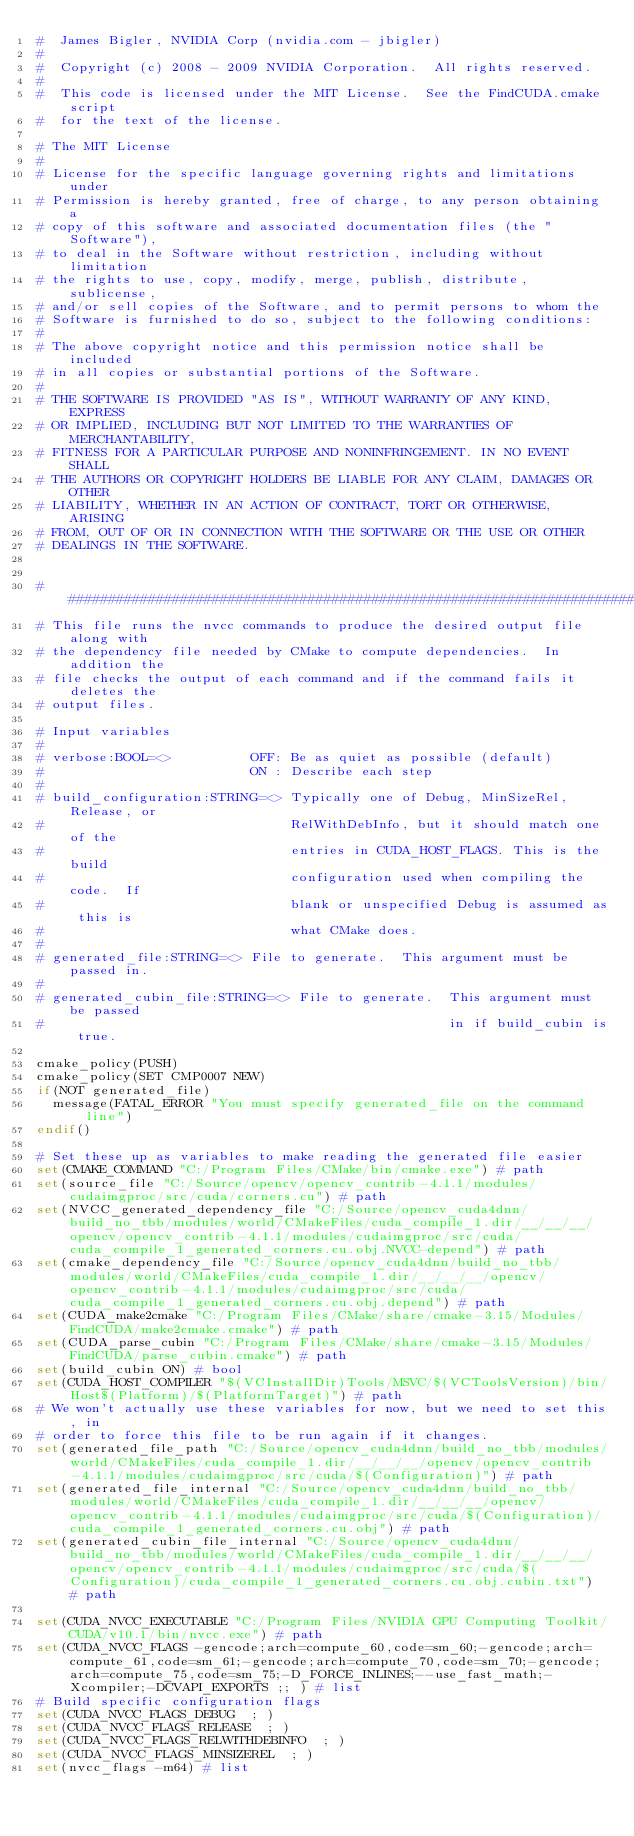<code> <loc_0><loc_0><loc_500><loc_500><_CMake_>#  James Bigler, NVIDIA Corp (nvidia.com - jbigler)
#
#  Copyright (c) 2008 - 2009 NVIDIA Corporation.  All rights reserved.
#
#  This code is licensed under the MIT License.  See the FindCUDA.cmake script
#  for the text of the license.

# The MIT License
#
# License for the specific language governing rights and limitations under
# Permission is hereby granted, free of charge, to any person obtaining a
# copy of this software and associated documentation files (the "Software"),
# to deal in the Software without restriction, including without limitation
# the rights to use, copy, modify, merge, publish, distribute, sublicense,
# and/or sell copies of the Software, and to permit persons to whom the
# Software is furnished to do so, subject to the following conditions:
#
# The above copyright notice and this permission notice shall be included
# in all copies or substantial portions of the Software.
#
# THE SOFTWARE IS PROVIDED "AS IS", WITHOUT WARRANTY OF ANY KIND, EXPRESS
# OR IMPLIED, INCLUDING BUT NOT LIMITED TO THE WARRANTIES OF MERCHANTABILITY,
# FITNESS FOR A PARTICULAR PURPOSE AND NONINFRINGEMENT. IN NO EVENT SHALL
# THE AUTHORS OR COPYRIGHT HOLDERS BE LIABLE FOR ANY CLAIM, DAMAGES OR OTHER
# LIABILITY, WHETHER IN AN ACTION OF CONTRACT, TORT OR OTHERWISE, ARISING
# FROM, OUT OF OR IN CONNECTION WITH THE SOFTWARE OR THE USE OR OTHER
# DEALINGS IN THE SOFTWARE.


##########################################################################
# This file runs the nvcc commands to produce the desired output file along with
# the dependency file needed by CMake to compute dependencies.  In addition the
# file checks the output of each command and if the command fails it deletes the
# output files.

# Input variables
#
# verbose:BOOL=<>          OFF: Be as quiet as possible (default)
#                          ON : Describe each step
#
# build_configuration:STRING=<> Typically one of Debug, MinSizeRel, Release, or
#                               RelWithDebInfo, but it should match one of the
#                               entries in CUDA_HOST_FLAGS. This is the build
#                               configuration used when compiling the code.  If
#                               blank or unspecified Debug is assumed as this is
#                               what CMake does.
#
# generated_file:STRING=<> File to generate.  This argument must be passed in.
#
# generated_cubin_file:STRING=<> File to generate.  This argument must be passed
#                                                   in if build_cubin is true.

cmake_policy(PUSH)
cmake_policy(SET CMP0007 NEW)
if(NOT generated_file)
  message(FATAL_ERROR "You must specify generated_file on the command line")
endif()

# Set these up as variables to make reading the generated file easier
set(CMAKE_COMMAND "C:/Program Files/CMake/bin/cmake.exe") # path
set(source_file "C:/Source/opencv/opencv_contrib-4.1.1/modules/cudaimgproc/src/cuda/corners.cu") # path
set(NVCC_generated_dependency_file "C:/Source/opencv_cuda4dnn/build_no_tbb/modules/world/CMakeFiles/cuda_compile_1.dir/__/__/__/opencv/opencv_contrib-4.1.1/modules/cudaimgproc/src/cuda/cuda_compile_1_generated_corners.cu.obj.NVCC-depend") # path
set(cmake_dependency_file "C:/Source/opencv_cuda4dnn/build_no_tbb/modules/world/CMakeFiles/cuda_compile_1.dir/__/__/__/opencv/opencv_contrib-4.1.1/modules/cudaimgproc/src/cuda/cuda_compile_1_generated_corners.cu.obj.depend") # path
set(CUDA_make2cmake "C:/Program Files/CMake/share/cmake-3.15/Modules/FindCUDA/make2cmake.cmake") # path
set(CUDA_parse_cubin "C:/Program Files/CMake/share/cmake-3.15/Modules/FindCUDA/parse_cubin.cmake") # path
set(build_cubin ON) # bool
set(CUDA_HOST_COMPILER "$(VCInstallDir)Tools/MSVC/$(VCToolsVersion)/bin/Host$(Platform)/$(PlatformTarget)") # path
# We won't actually use these variables for now, but we need to set this, in
# order to force this file to be run again if it changes.
set(generated_file_path "C:/Source/opencv_cuda4dnn/build_no_tbb/modules/world/CMakeFiles/cuda_compile_1.dir/__/__/__/opencv/opencv_contrib-4.1.1/modules/cudaimgproc/src/cuda/$(Configuration)") # path
set(generated_file_internal "C:/Source/opencv_cuda4dnn/build_no_tbb/modules/world/CMakeFiles/cuda_compile_1.dir/__/__/__/opencv/opencv_contrib-4.1.1/modules/cudaimgproc/src/cuda/$(Configuration)/cuda_compile_1_generated_corners.cu.obj") # path
set(generated_cubin_file_internal "C:/Source/opencv_cuda4dnn/build_no_tbb/modules/world/CMakeFiles/cuda_compile_1.dir/__/__/__/opencv/opencv_contrib-4.1.1/modules/cudaimgproc/src/cuda/$(Configuration)/cuda_compile_1_generated_corners.cu.obj.cubin.txt") # path

set(CUDA_NVCC_EXECUTABLE "C:/Program Files/NVIDIA GPU Computing Toolkit/CUDA/v10.1/bin/nvcc.exe") # path
set(CUDA_NVCC_FLAGS -gencode;arch=compute_60,code=sm_60;-gencode;arch=compute_61,code=sm_61;-gencode;arch=compute_70,code=sm_70;-gencode;arch=compute_75,code=sm_75;-D_FORCE_INLINES;--use_fast_math;-Xcompiler;-DCVAPI_EXPORTS ;; ) # list
# Build specific configuration flags
set(CUDA_NVCC_FLAGS_DEBUG  ; )
set(CUDA_NVCC_FLAGS_RELEASE  ; )
set(CUDA_NVCC_FLAGS_RELWITHDEBINFO  ; )
set(CUDA_NVCC_FLAGS_MINSIZEREL  ; )
set(nvcc_flags -m64) # list</code> 